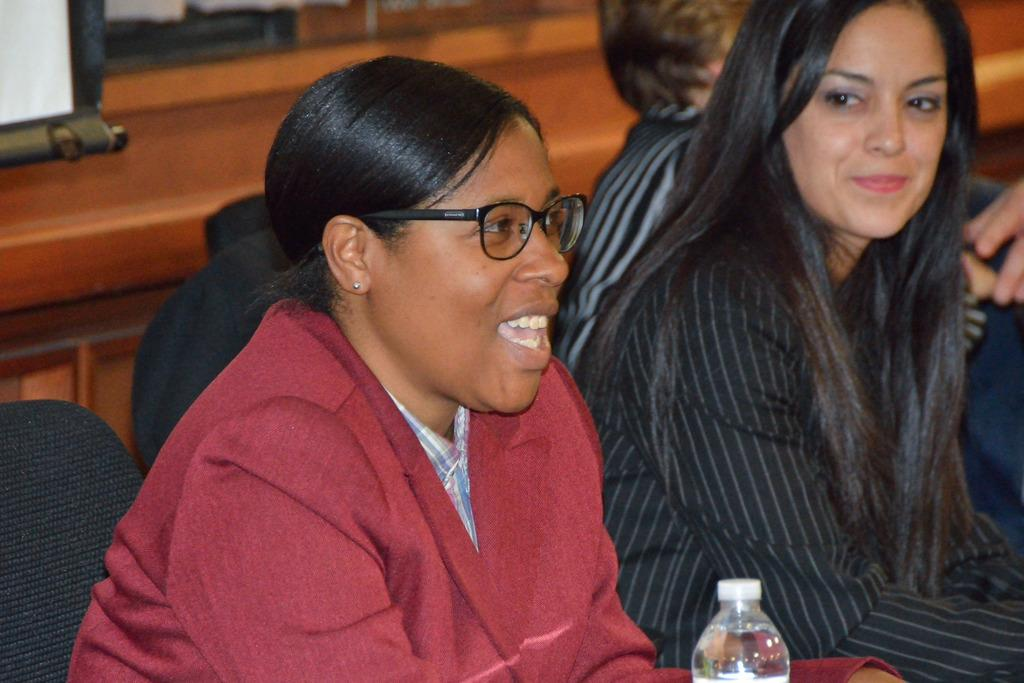How many people are in the image? There are two women in the image. What are the women doing in the image? The women are sitting on a chair. Can you describe any accessories worn by one of the women? One of the women is wearing glasses (specs). What is the purpose of the object visible in the image? There is a water bottle in the image, which is likely for drinking water. What type of scarf is draped over the chair in the image? There is no scarf present in the image; only the two women and a water bottle are visible. 